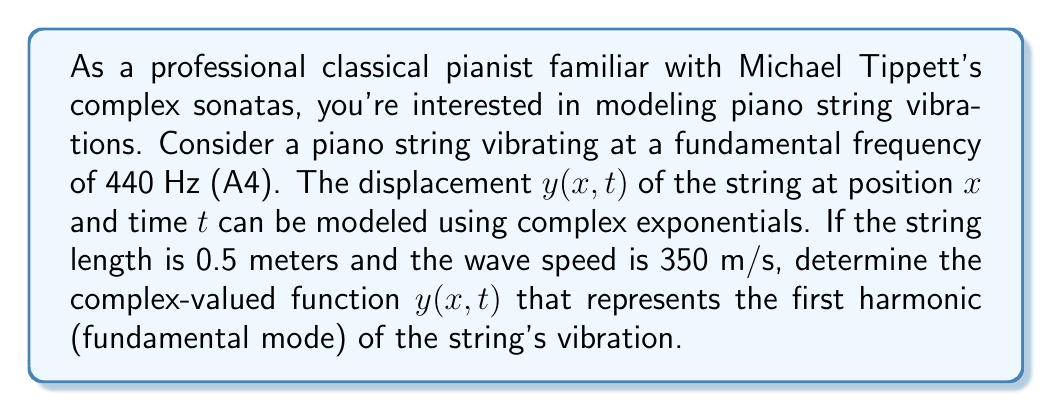Give your solution to this math problem. To model the piano string vibration using complex exponentials, we'll follow these steps:

1) The general form of a complex-valued function for a standing wave is:

   $$y(x,t) = Ae^{i(kx - \omega t)}$$

   where $A$ is the amplitude, $k$ is the wave number, and $\omega$ is the angular frequency.

2) We're given the fundamental frequency $f = 440$ Hz. The angular frequency $\omega$ is:

   $$\omega = 2\pi f = 2\pi(440) \approx 2763.89 \text{ rad/s}$$

3) The wave number $k$ for the first harmonic (fundamental mode) is:

   $$k = \frac{\pi}{L} = \frac{\pi}{0.5} = 2\pi \text{ rad/m}$$

   where $L$ is the length of the string.

4) We can verify this using the wave equation: $v = f\lambda$
   
   $$350 = 440 \cdot \frac{2L}{1} = 440 \cdot 1 = 440 \text{ m/s}$$

5) The amplitude $A$ is arbitrary for this problem, so let's use $A = 1$ for simplicity.

6) Substituting these values into our general equation:

   $$y(x,t) = e^{i(2\pi x - 2763.89t)}$$

This function represents a wave traveling in the positive x-direction. To create a standing wave, we need to add its reflection:

$$y(x,t) = e^{i(2\pi x - 2763.89t)} + e^{i(-2\pi x - 2763.89t)}$$

Which can be simplified using Euler's formula:

$$y(x,t) = 2\cos(2\pi x)e^{-i2763.89t}$$
Answer: $$y(x,t) = 2\cos(2\pi x)e^{-i2763.89t}$$ 